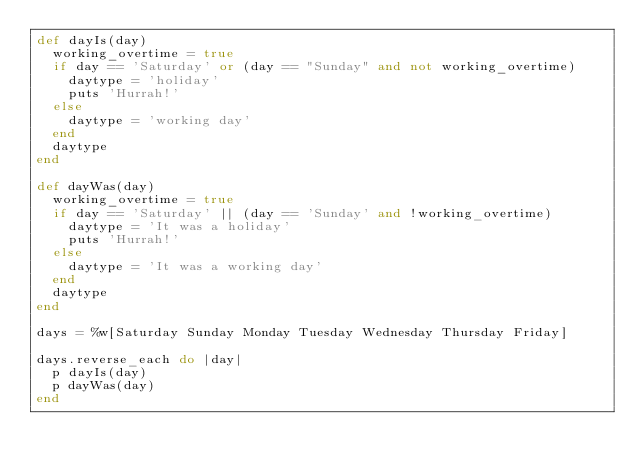Convert code to text. <code><loc_0><loc_0><loc_500><loc_500><_Ruby_>def dayIs(day)
  working_overtime = true
  if day == 'Saturday' or (day == "Sunday" and not working_overtime)
    daytype = 'holiday'
    puts 'Hurrah!'
  else
    daytype = 'working day'
  end
  daytype
end

def dayWas(day)
  working_overtime = true
  if day == 'Saturday' || (day == 'Sunday' and !working_overtime)
    daytype = 'It was a holiday'
    puts 'Hurrah!'
  else
    daytype = 'It was a working day'
  end
  daytype
end

days = %w[Saturday Sunday Monday Tuesday Wednesday Thursday Friday]

days.reverse_each do |day|
  p dayIs(day)
  p dayWas(day)
end
</code> 